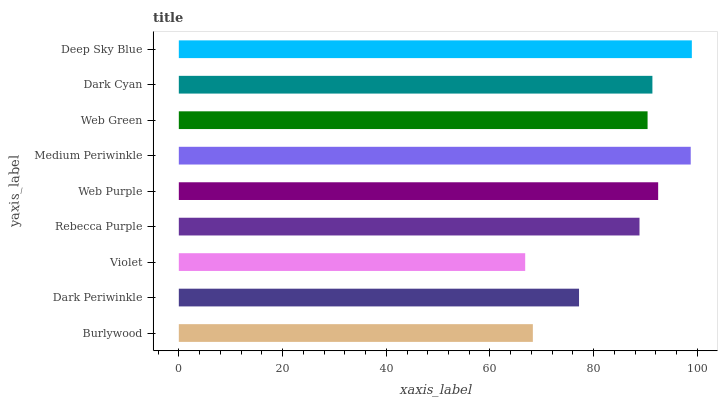Is Violet the minimum?
Answer yes or no. Yes. Is Deep Sky Blue the maximum?
Answer yes or no. Yes. Is Dark Periwinkle the minimum?
Answer yes or no. No. Is Dark Periwinkle the maximum?
Answer yes or no. No. Is Dark Periwinkle greater than Burlywood?
Answer yes or no. Yes. Is Burlywood less than Dark Periwinkle?
Answer yes or no. Yes. Is Burlywood greater than Dark Periwinkle?
Answer yes or no. No. Is Dark Periwinkle less than Burlywood?
Answer yes or no. No. Is Web Green the high median?
Answer yes or no. Yes. Is Web Green the low median?
Answer yes or no. Yes. Is Burlywood the high median?
Answer yes or no. No. Is Web Purple the low median?
Answer yes or no. No. 